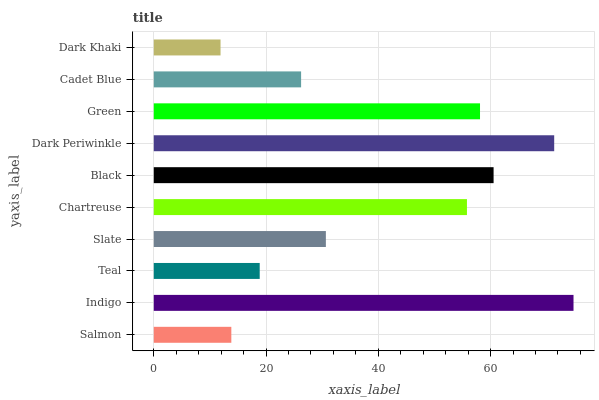Is Dark Khaki the minimum?
Answer yes or no. Yes. Is Indigo the maximum?
Answer yes or no. Yes. Is Teal the minimum?
Answer yes or no. No. Is Teal the maximum?
Answer yes or no. No. Is Indigo greater than Teal?
Answer yes or no. Yes. Is Teal less than Indigo?
Answer yes or no. Yes. Is Teal greater than Indigo?
Answer yes or no. No. Is Indigo less than Teal?
Answer yes or no. No. Is Chartreuse the high median?
Answer yes or no. Yes. Is Slate the low median?
Answer yes or no. Yes. Is Cadet Blue the high median?
Answer yes or no. No. Is Chartreuse the low median?
Answer yes or no. No. 